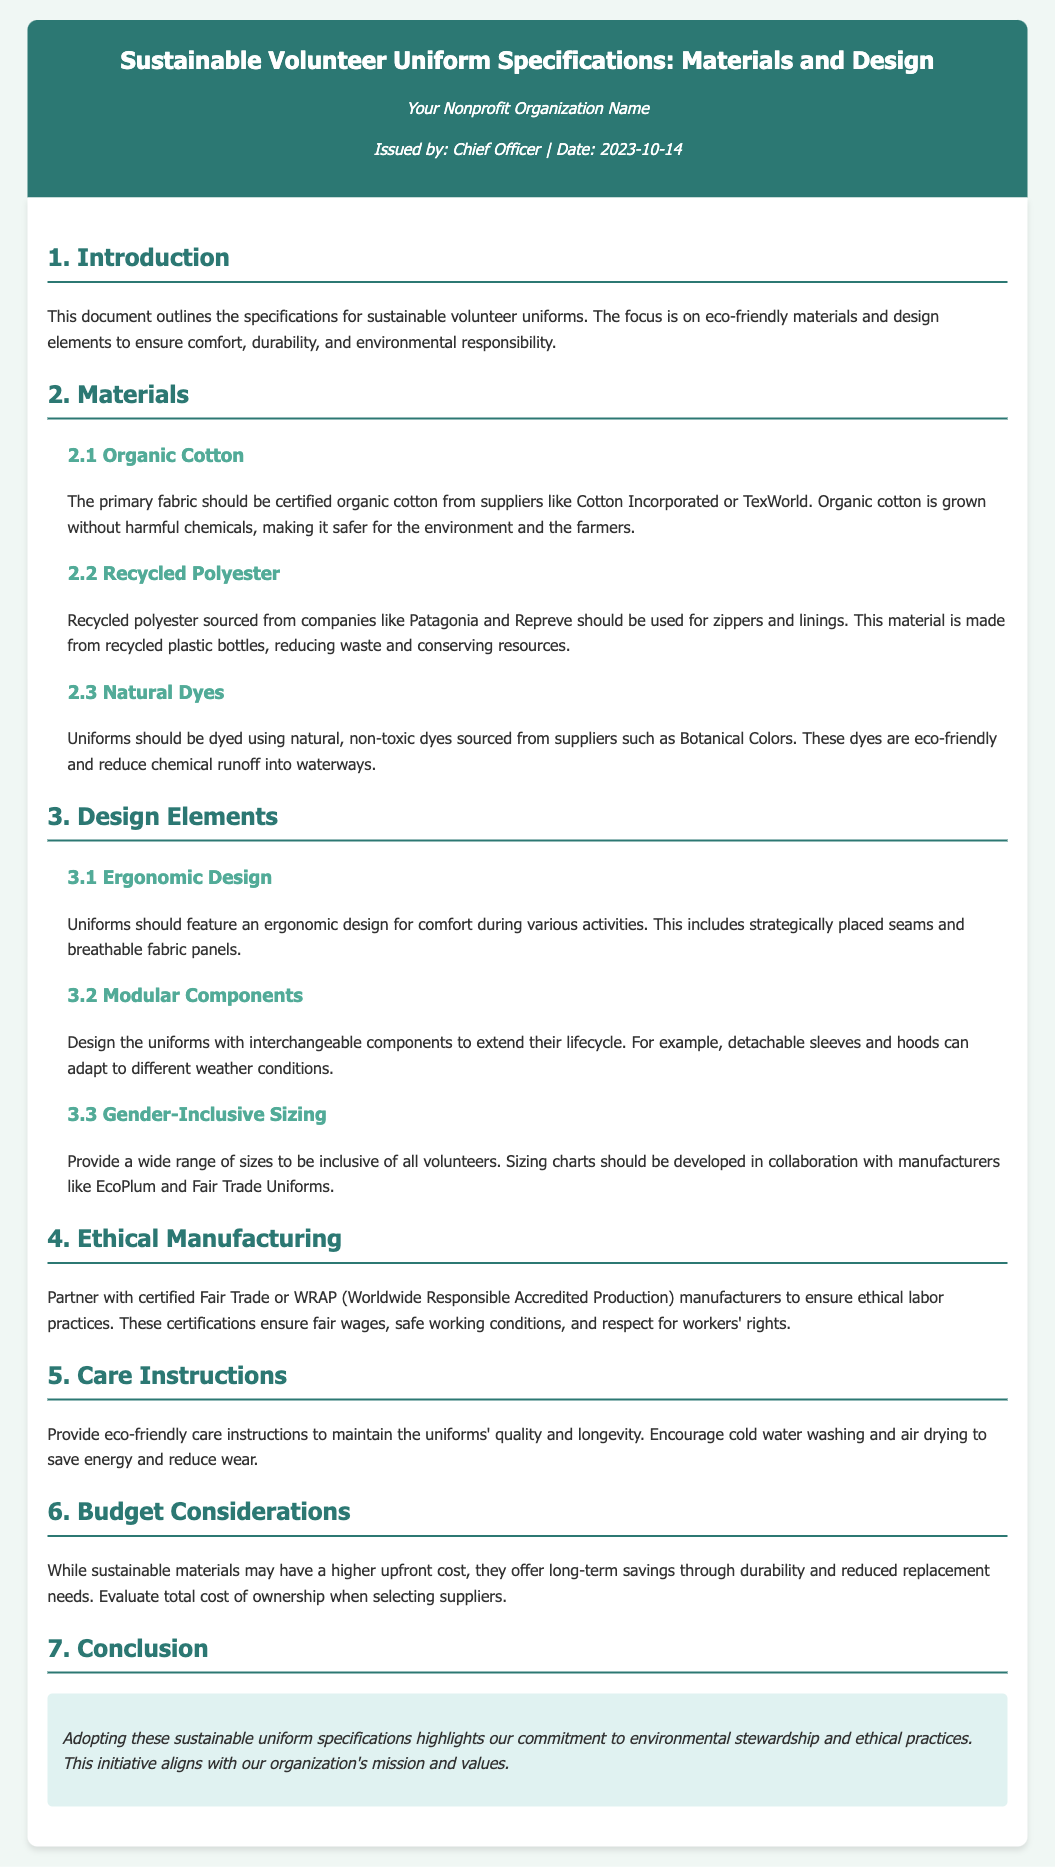What is the primary fabric for the uniforms? The document states that the primary fabric should be certified organic cotton.
Answer: organic cotton Who should provide the recycled polyester? The document mentions that recycled polyester should be sourced from companies like Patagonia and Repreve.
Answer: Patagonia and Repreve What type of dyes should be used for the uniforms? The document specifies that uniforms should be dyed using natural, non-toxic dyes.
Answer: natural, non-toxic dyes What design feature is aimed at comfort during activities? The document highlights that uniforms should feature an ergonomic design for comfort.
Answer: ergonomic design What is the purpose of modular components in the design? The document indicates that modular components are designed to extend the lifecycle of the uniforms.
Answer: extend their lifecycle What standards should manufacturers meet for ethical practices? The document states that manufacturers should be certified Fair Trade or WRAP.
Answer: Fair Trade or WRAP What care instructions are suggested for maintaining the uniforms? The document encourages cold water washing and air drying to maintain quality.
Answer: cold water washing and air drying What date was this specification sheet issued? The document clearly states that it was issued on 2023-10-14.
Answer: 2023-10-14 What is the conclusion about adopting these specifications? The conclusion emphasizes the commitment to environmental stewardship and ethical practices.
Answer: commitment to environmental stewardship and ethical practices 